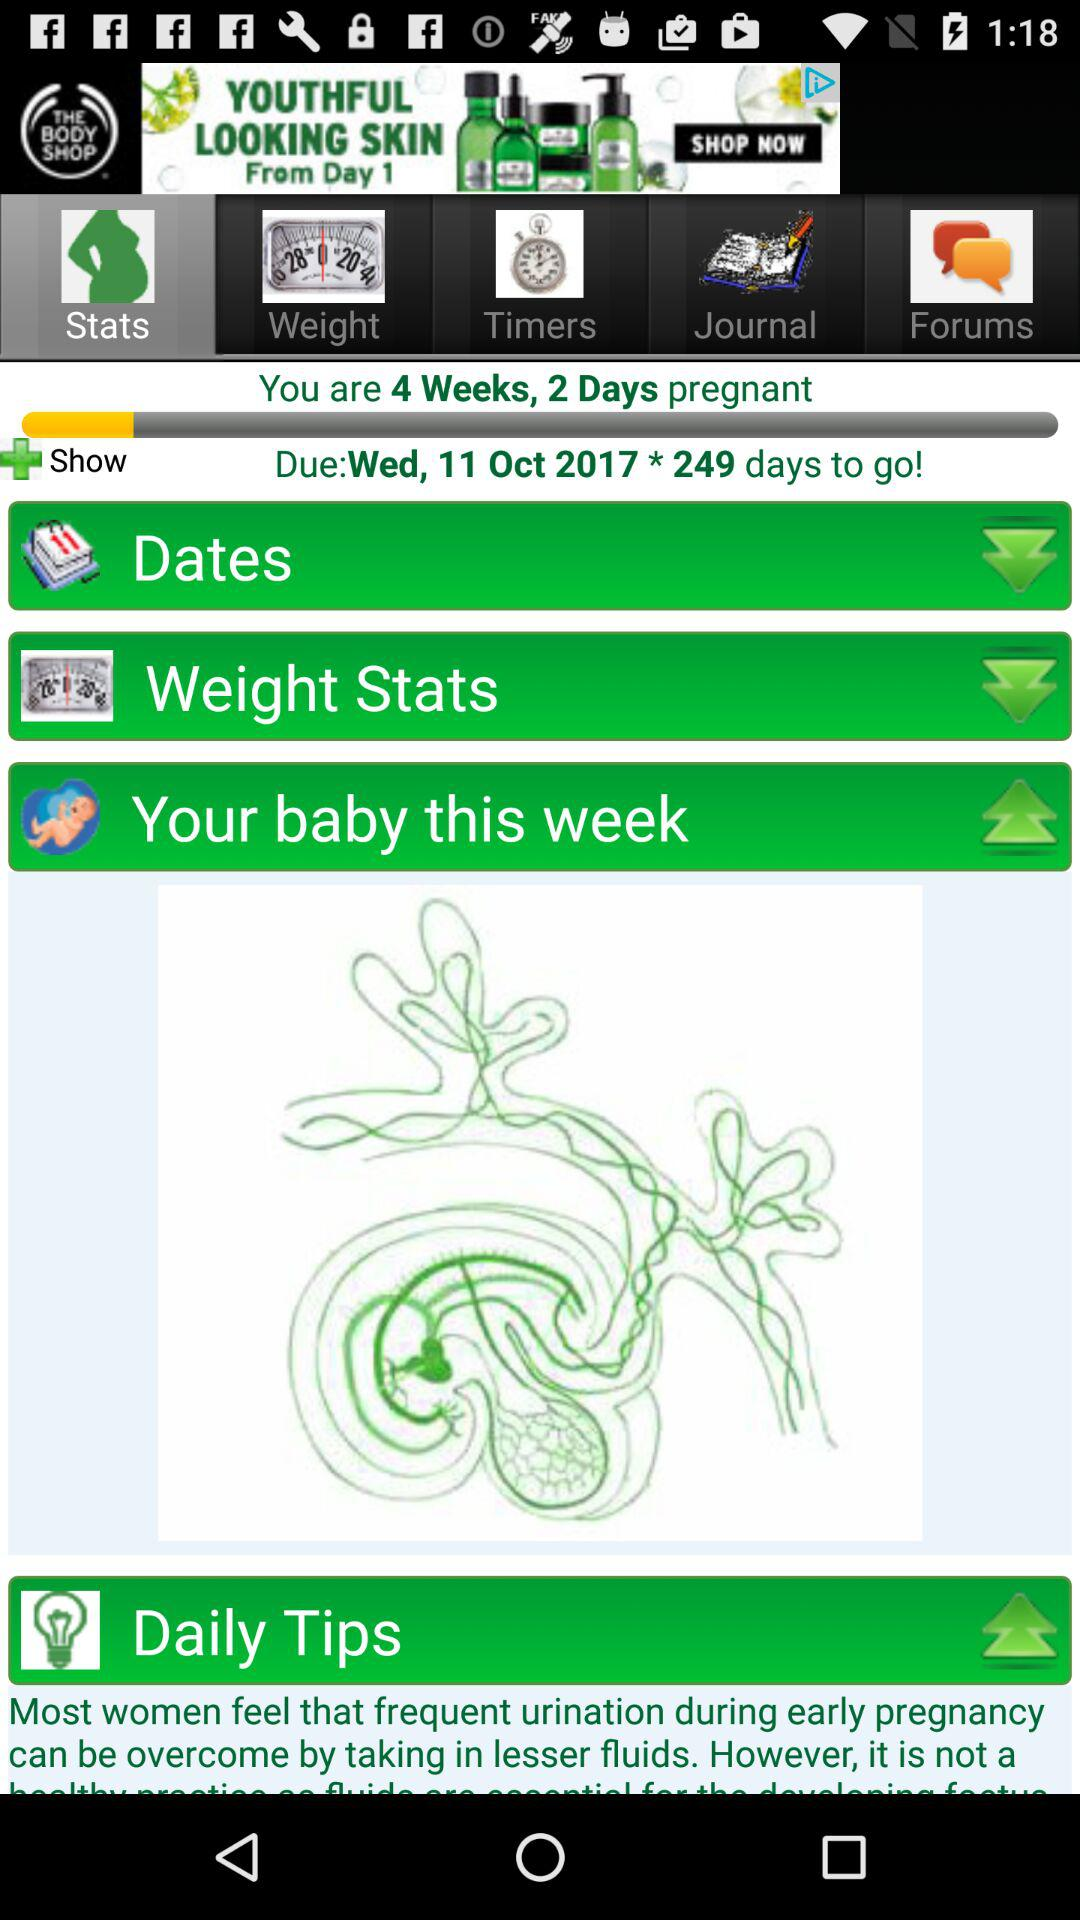Which tab is selected? The selected tab is "Stats". 